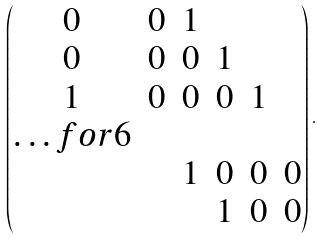Convert formula to latex. <formula><loc_0><loc_0><loc_500><loc_500>\begin{pmatrix} 0 & 0 & 1 \\ 0 & 0 & 0 & 1 \\ 1 & 0 & 0 & 0 & 1 \\ \hdots f o r { 6 } \\ & & 1 & 0 & 0 & 0 \\ & & & 1 & 0 & 0 \end{pmatrix} .</formula> 